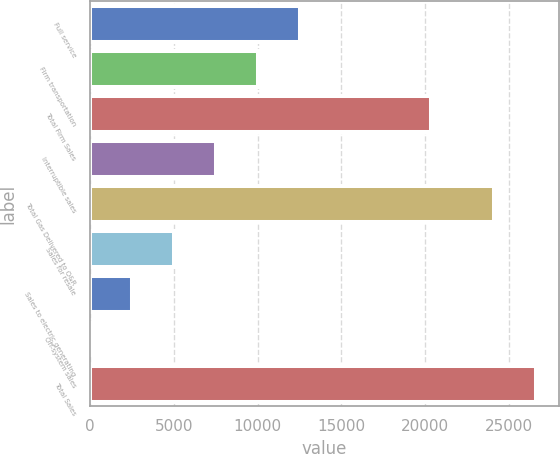Convert chart. <chart><loc_0><loc_0><loc_500><loc_500><bar_chart><fcel>Full service<fcel>Firm transportation<fcel>Total Firm Sales<fcel>Interruptible sales<fcel>Total Gas Delivered to O&R<fcel>Sales for resale<fcel>Sales to electric generating<fcel>Off-system sales<fcel>Total Sales<nl><fcel>12520.5<fcel>10017.6<fcel>20353<fcel>7514.7<fcel>24124<fcel>5011.8<fcel>2508.9<fcel>6<fcel>26626.9<nl></chart> 